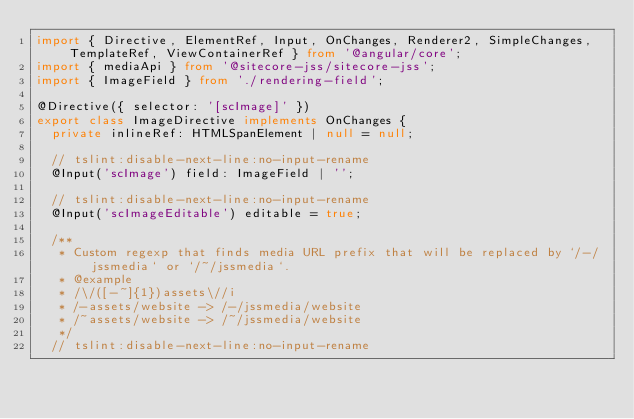<code> <loc_0><loc_0><loc_500><loc_500><_TypeScript_>import { Directive, ElementRef, Input, OnChanges, Renderer2, SimpleChanges, TemplateRef, ViewContainerRef } from '@angular/core';
import { mediaApi } from '@sitecore-jss/sitecore-jss';
import { ImageField } from './rendering-field';

@Directive({ selector: '[scImage]' })
export class ImageDirective implements OnChanges {
  private inlineRef: HTMLSpanElement | null = null;

  // tslint:disable-next-line:no-input-rename
  @Input('scImage') field: ImageField | '';

  // tslint:disable-next-line:no-input-rename
  @Input('scImageEditable') editable = true;

  /**
   * Custom regexp that finds media URL prefix that will be replaced by `/-/jssmedia` or `/~/jssmedia`.
   * @example
   * /\/([-~]{1})assets\//i
   * /-assets/website -> /-/jssmedia/website
   * /~assets/website -> /~/jssmedia/website
   */
  // tslint:disable-next-line:no-input-rename</code> 